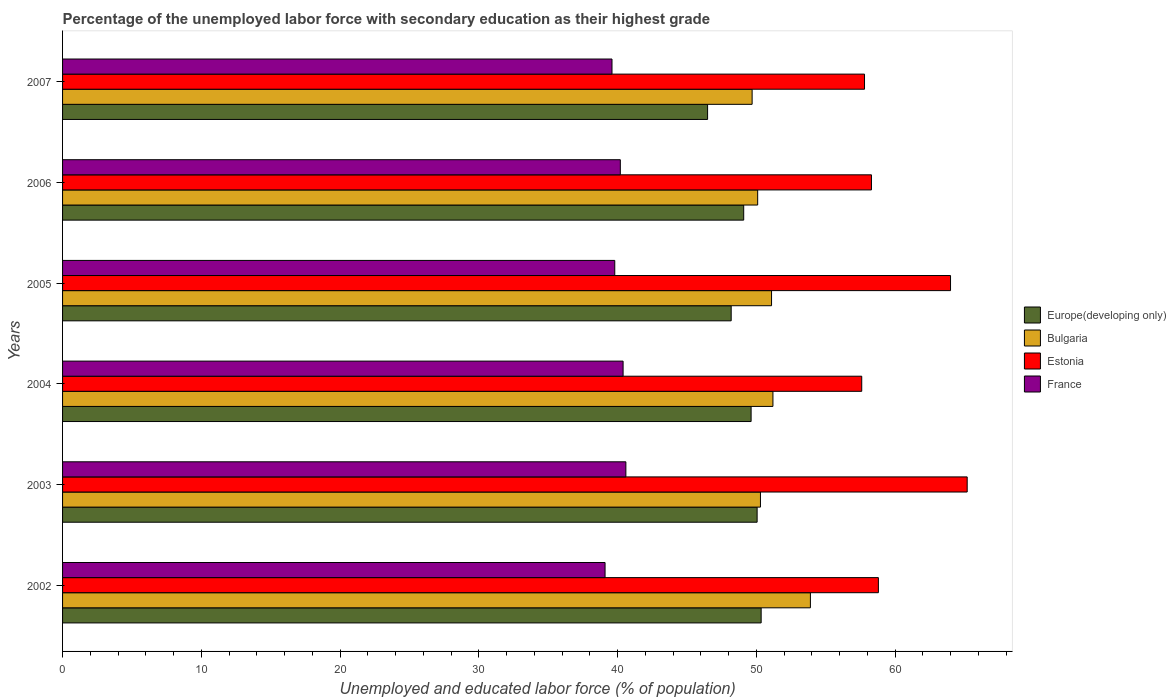How many different coloured bars are there?
Your response must be concise. 4. How many groups of bars are there?
Your response must be concise. 6. Are the number of bars per tick equal to the number of legend labels?
Your response must be concise. Yes. Are the number of bars on each tick of the Y-axis equal?
Keep it short and to the point. Yes. How many bars are there on the 5th tick from the top?
Offer a very short reply. 4. How many bars are there on the 6th tick from the bottom?
Ensure brevity in your answer.  4. What is the label of the 4th group of bars from the top?
Your answer should be very brief. 2004. In how many cases, is the number of bars for a given year not equal to the number of legend labels?
Your answer should be compact. 0. What is the percentage of the unemployed labor force with secondary education in Europe(developing only) in 2003?
Give a very brief answer. 50.06. Across all years, what is the maximum percentage of the unemployed labor force with secondary education in France?
Your response must be concise. 40.6. Across all years, what is the minimum percentage of the unemployed labor force with secondary education in Europe(developing only)?
Provide a succinct answer. 46.49. What is the total percentage of the unemployed labor force with secondary education in Europe(developing only) in the graph?
Make the answer very short. 293.81. What is the difference between the percentage of the unemployed labor force with secondary education in Europe(developing only) in 2002 and that in 2006?
Your answer should be very brief. 1.26. What is the difference between the percentage of the unemployed labor force with secondary education in Bulgaria in 2004 and the percentage of the unemployed labor force with secondary education in Europe(developing only) in 2002?
Offer a very short reply. 0.85. What is the average percentage of the unemployed labor force with secondary education in Bulgaria per year?
Provide a short and direct response. 51.05. In the year 2003, what is the difference between the percentage of the unemployed labor force with secondary education in France and percentage of the unemployed labor force with secondary education in Estonia?
Keep it short and to the point. -24.6. What is the ratio of the percentage of the unemployed labor force with secondary education in Bulgaria in 2002 to that in 2004?
Provide a succinct answer. 1.05. What is the difference between the highest and the second highest percentage of the unemployed labor force with secondary education in Estonia?
Make the answer very short. 1.2. Is the sum of the percentage of the unemployed labor force with secondary education in Bulgaria in 2004 and 2005 greater than the maximum percentage of the unemployed labor force with secondary education in Estonia across all years?
Keep it short and to the point. Yes. Is it the case that in every year, the sum of the percentage of the unemployed labor force with secondary education in France and percentage of the unemployed labor force with secondary education in Europe(developing only) is greater than the sum of percentage of the unemployed labor force with secondary education in Bulgaria and percentage of the unemployed labor force with secondary education in Estonia?
Keep it short and to the point. No. What does the 3rd bar from the bottom in 2007 represents?
Keep it short and to the point. Estonia. Is it the case that in every year, the sum of the percentage of the unemployed labor force with secondary education in Europe(developing only) and percentage of the unemployed labor force with secondary education in France is greater than the percentage of the unemployed labor force with secondary education in Estonia?
Give a very brief answer. Yes. Are all the bars in the graph horizontal?
Give a very brief answer. Yes. How many years are there in the graph?
Your answer should be compact. 6. What is the difference between two consecutive major ticks on the X-axis?
Make the answer very short. 10. Are the values on the major ticks of X-axis written in scientific E-notation?
Make the answer very short. No. Does the graph contain grids?
Provide a short and direct response. No. How many legend labels are there?
Give a very brief answer. 4. How are the legend labels stacked?
Ensure brevity in your answer.  Vertical. What is the title of the graph?
Provide a short and direct response. Percentage of the unemployed labor force with secondary education as their highest grade. What is the label or title of the X-axis?
Keep it short and to the point. Unemployed and educated labor force (% of population). What is the label or title of the Y-axis?
Keep it short and to the point. Years. What is the Unemployed and educated labor force (% of population) of Europe(developing only) in 2002?
Make the answer very short. 50.35. What is the Unemployed and educated labor force (% of population) of Bulgaria in 2002?
Make the answer very short. 53.9. What is the Unemployed and educated labor force (% of population) of Estonia in 2002?
Your answer should be compact. 58.8. What is the Unemployed and educated labor force (% of population) in France in 2002?
Provide a short and direct response. 39.1. What is the Unemployed and educated labor force (% of population) in Europe(developing only) in 2003?
Offer a very short reply. 50.06. What is the Unemployed and educated labor force (% of population) of Bulgaria in 2003?
Offer a very short reply. 50.3. What is the Unemployed and educated labor force (% of population) in Estonia in 2003?
Your answer should be compact. 65.2. What is the Unemployed and educated labor force (% of population) of France in 2003?
Your answer should be compact. 40.6. What is the Unemployed and educated labor force (% of population) in Europe(developing only) in 2004?
Make the answer very short. 49.63. What is the Unemployed and educated labor force (% of population) of Bulgaria in 2004?
Your response must be concise. 51.2. What is the Unemployed and educated labor force (% of population) of Estonia in 2004?
Ensure brevity in your answer.  57.6. What is the Unemployed and educated labor force (% of population) of France in 2004?
Provide a short and direct response. 40.4. What is the Unemployed and educated labor force (% of population) of Europe(developing only) in 2005?
Your response must be concise. 48.19. What is the Unemployed and educated labor force (% of population) of Bulgaria in 2005?
Keep it short and to the point. 51.1. What is the Unemployed and educated labor force (% of population) in Estonia in 2005?
Offer a terse response. 64. What is the Unemployed and educated labor force (% of population) in France in 2005?
Your response must be concise. 39.8. What is the Unemployed and educated labor force (% of population) in Europe(developing only) in 2006?
Offer a terse response. 49.09. What is the Unemployed and educated labor force (% of population) of Bulgaria in 2006?
Your response must be concise. 50.1. What is the Unemployed and educated labor force (% of population) of Estonia in 2006?
Offer a terse response. 58.3. What is the Unemployed and educated labor force (% of population) of France in 2006?
Provide a succinct answer. 40.2. What is the Unemployed and educated labor force (% of population) in Europe(developing only) in 2007?
Offer a terse response. 46.49. What is the Unemployed and educated labor force (% of population) of Bulgaria in 2007?
Your response must be concise. 49.7. What is the Unemployed and educated labor force (% of population) of Estonia in 2007?
Your answer should be compact. 57.8. What is the Unemployed and educated labor force (% of population) in France in 2007?
Offer a terse response. 39.6. Across all years, what is the maximum Unemployed and educated labor force (% of population) of Europe(developing only)?
Give a very brief answer. 50.35. Across all years, what is the maximum Unemployed and educated labor force (% of population) in Bulgaria?
Provide a succinct answer. 53.9. Across all years, what is the maximum Unemployed and educated labor force (% of population) in Estonia?
Make the answer very short. 65.2. Across all years, what is the maximum Unemployed and educated labor force (% of population) of France?
Make the answer very short. 40.6. Across all years, what is the minimum Unemployed and educated labor force (% of population) in Europe(developing only)?
Your answer should be compact. 46.49. Across all years, what is the minimum Unemployed and educated labor force (% of population) of Bulgaria?
Offer a terse response. 49.7. Across all years, what is the minimum Unemployed and educated labor force (% of population) in Estonia?
Your answer should be compact. 57.6. Across all years, what is the minimum Unemployed and educated labor force (% of population) of France?
Your answer should be very brief. 39.1. What is the total Unemployed and educated labor force (% of population) of Europe(developing only) in the graph?
Offer a terse response. 293.81. What is the total Unemployed and educated labor force (% of population) in Bulgaria in the graph?
Make the answer very short. 306.3. What is the total Unemployed and educated labor force (% of population) of Estonia in the graph?
Offer a terse response. 361.7. What is the total Unemployed and educated labor force (% of population) of France in the graph?
Your response must be concise. 239.7. What is the difference between the Unemployed and educated labor force (% of population) of Europe(developing only) in 2002 and that in 2003?
Offer a very short reply. 0.29. What is the difference between the Unemployed and educated labor force (% of population) of Bulgaria in 2002 and that in 2003?
Give a very brief answer. 3.6. What is the difference between the Unemployed and educated labor force (% of population) in Estonia in 2002 and that in 2003?
Your answer should be compact. -6.4. What is the difference between the Unemployed and educated labor force (% of population) in Europe(developing only) in 2002 and that in 2004?
Make the answer very short. 0.72. What is the difference between the Unemployed and educated labor force (% of population) of Bulgaria in 2002 and that in 2004?
Your answer should be very brief. 2.7. What is the difference between the Unemployed and educated labor force (% of population) in Estonia in 2002 and that in 2004?
Give a very brief answer. 1.2. What is the difference between the Unemployed and educated labor force (% of population) in France in 2002 and that in 2004?
Give a very brief answer. -1.3. What is the difference between the Unemployed and educated labor force (% of population) in Europe(developing only) in 2002 and that in 2005?
Your answer should be very brief. 2.16. What is the difference between the Unemployed and educated labor force (% of population) of Estonia in 2002 and that in 2005?
Your answer should be compact. -5.2. What is the difference between the Unemployed and educated labor force (% of population) in France in 2002 and that in 2005?
Give a very brief answer. -0.7. What is the difference between the Unemployed and educated labor force (% of population) in Europe(developing only) in 2002 and that in 2006?
Your response must be concise. 1.26. What is the difference between the Unemployed and educated labor force (% of population) in France in 2002 and that in 2006?
Provide a succinct answer. -1.1. What is the difference between the Unemployed and educated labor force (% of population) of Europe(developing only) in 2002 and that in 2007?
Provide a succinct answer. 3.86. What is the difference between the Unemployed and educated labor force (% of population) of Bulgaria in 2002 and that in 2007?
Your answer should be very brief. 4.2. What is the difference between the Unemployed and educated labor force (% of population) of Estonia in 2002 and that in 2007?
Ensure brevity in your answer.  1. What is the difference between the Unemployed and educated labor force (% of population) of Europe(developing only) in 2003 and that in 2004?
Make the answer very short. 0.43. What is the difference between the Unemployed and educated labor force (% of population) in Bulgaria in 2003 and that in 2004?
Offer a terse response. -0.9. What is the difference between the Unemployed and educated labor force (% of population) of Estonia in 2003 and that in 2004?
Offer a very short reply. 7.6. What is the difference between the Unemployed and educated labor force (% of population) in Europe(developing only) in 2003 and that in 2005?
Your response must be concise. 1.87. What is the difference between the Unemployed and educated labor force (% of population) in Estonia in 2003 and that in 2005?
Provide a succinct answer. 1.2. What is the difference between the Unemployed and educated labor force (% of population) in France in 2003 and that in 2005?
Ensure brevity in your answer.  0.8. What is the difference between the Unemployed and educated labor force (% of population) of Europe(developing only) in 2003 and that in 2006?
Give a very brief answer. 0.97. What is the difference between the Unemployed and educated labor force (% of population) in France in 2003 and that in 2006?
Provide a succinct answer. 0.4. What is the difference between the Unemployed and educated labor force (% of population) of Europe(developing only) in 2003 and that in 2007?
Provide a succinct answer. 3.57. What is the difference between the Unemployed and educated labor force (% of population) in Estonia in 2003 and that in 2007?
Give a very brief answer. 7.4. What is the difference between the Unemployed and educated labor force (% of population) in Europe(developing only) in 2004 and that in 2005?
Ensure brevity in your answer.  1.44. What is the difference between the Unemployed and educated labor force (% of population) of Bulgaria in 2004 and that in 2005?
Provide a short and direct response. 0.1. What is the difference between the Unemployed and educated labor force (% of population) of France in 2004 and that in 2005?
Give a very brief answer. 0.6. What is the difference between the Unemployed and educated labor force (% of population) in Europe(developing only) in 2004 and that in 2006?
Your answer should be compact. 0.53. What is the difference between the Unemployed and educated labor force (% of population) of Bulgaria in 2004 and that in 2006?
Your response must be concise. 1.1. What is the difference between the Unemployed and educated labor force (% of population) in Europe(developing only) in 2004 and that in 2007?
Make the answer very short. 3.14. What is the difference between the Unemployed and educated labor force (% of population) in Estonia in 2004 and that in 2007?
Provide a succinct answer. -0.2. What is the difference between the Unemployed and educated labor force (% of population) in France in 2004 and that in 2007?
Your answer should be very brief. 0.8. What is the difference between the Unemployed and educated labor force (% of population) of Europe(developing only) in 2005 and that in 2006?
Make the answer very short. -0.9. What is the difference between the Unemployed and educated labor force (% of population) in Bulgaria in 2005 and that in 2006?
Make the answer very short. 1. What is the difference between the Unemployed and educated labor force (% of population) in Estonia in 2005 and that in 2006?
Offer a terse response. 5.7. What is the difference between the Unemployed and educated labor force (% of population) of Europe(developing only) in 2005 and that in 2007?
Offer a terse response. 1.7. What is the difference between the Unemployed and educated labor force (% of population) in Europe(developing only) in 2006 and that in 2007?
Your answer should be compact. 2.6. What is the difference between the Unemployed and educated labor force (% of population) of Europe(developing only) in 2002 and the Unemployed and educated labor force (% of population) of Bulgaria in 2003?
Keep it short and to the point. 0.05. What is the difference between the Unemployed and educated labor force (% of population) in Europe(developing only) in 2002 and the Unemployed and educated labor force (% of population) in Estonia in 2003?
Ensure brevity in your answer.  -14.85. What is the difference between the Unemployed and educated labor force (% of population) in Europe(developing only) in 2002 and the Unemployed and educated labor force (% of population) in France in 2003?
Offer a very short reply. 9.75. What is the difference between the Unemployed and educated labor force (% of population) in Bulgaria in 2002 and the Unemployed and educated labor force (% of population) in Estonia in 2003?
Keep it short and to the point. -11.3. What is the difference between the Unemployed and educated labor force (% of population) in Bulgaria in 2002 and the Unemployed and educated labor force (% of population) in France in 2003?
Provide a short and direct response. 13.3. What is the difference between the Unemployed and educated labor force (% of population) in Estonia in 2002 and the Unemployed and educated labor force (% of population) in France in 2003?
Provide a short and direct response. 18.2. What is the difference between the Unemployed and educated labor force (% of population) in Europe(developing only) in 2002 and the Unemployed and educated labor force (% of population) in Bulgaria in 2004?
Your response must be concise. -0.85. What is the difference between the Unemployed and educated labor force (% of population) in Europe(developing only) in 2002 and the Unemployed and educated labor force (% of population) in Estonia in 2004?
Make the answer very short. -7.25. What is the difference between the Unemployed and educated labor force (% of population) of Europe(developing only) in 2002 and the Unemployed and educated labor force (% of population) of France in 2004?
Your response must be concise. 9.95. What is the difference between the Unemployed and educated labor force (% of population) of Europe(developing only) in 2002 and the Unemployed and educated labor force (% of population) of Bulgaria in 2005?
Provide a short and direct response. -0.75. What is the difference between the Unemployed and educated labor force (% of population) in Europe(developing only) in 2002 and the Unemployed and educated labor force (% of population) in Estonia in 2005?
Your answer should be compact. -13.65. What is the difference between the Unemployed and educated labor force (% of population) of Europe(developing only) in 2002 and the Unemployed and educated labor force (% of population) of France in 2005?
Keep it short and to the point. 10.55. What is the difference between the Unemployed and educated labor force (% of population) in Europe(developing only) in 2002 and the Unemployed and educated labor force (% of population) in Bulgaria in 2006?
Keep it short and to the point. 0.25. What is the difference between the Unemployed and educated labor force (% of population) in Europe(developing only) in 2002 and the Unemployed and educated labor force (% of population) in Estonia in 2006?
Keep it short and to the point. -7.95. What is the difference between the Unemployed and educated labor force (% of population) of Europe(developing only) in 2002 and the Unemployed and educated labor force (% of population) of France in 2006?
Provide a short and direct response. 10.15. What is the difference between the Unemployed and educated labor force (% of population) in Bulgaria in 2002 and the Unemployed and educated labor force (% of population) in Estonia in 2006?
Ensure brevity in your answer.  -4.4. What is the difference between the Unemployed and educated labor force (% of population) in Bulgaria in 2002 and the Unemployed and educated labor force (% of population) in France in 2006?
Your answer should be compact. 13.7. What is the difference between the Unemployed and educated labor force (% of population) of Estonia in 2002 and the Unemployed and educated labor force (% of population) of France in 2006?
Your response must be concise. 18.6. What is the difference between the Unemployed and educated labor force (% of population) of Europe(developing only) in 2002 and the Unemployed and educated labor force (% of population) of Bulgaria in 2007?
Your answer should be very brief. 0.65. What is the difference between the Unemployed and educated labor force (% of population) of Europe(developing only) in 2002 and the Unemployed and educated labor force (% of population) of Estonia in 2007?
Your answer should be compact. -7.45. What is the difference between the Unemployed and educated labor force (% of population) of Europe(developing only) in 2002 and the Unemployed and educated labor force (% of population) of France in 2007?
Offer a very short reply. 10.75. What is the difference between the Unemployed and educated labor force (% of population) in Bulgaria in 2002 and the Unemployed and educated labor force (% of population) in Estonia in 2007?
Ensure brevity in your answer.  -3.9. What is the difference between the Unemployed and educated labor force (% of population) of Estonia in 2002 and the Unemployed and educated labor force (% of population) of France in 2007?
Keep it short and to the point. 19.2. What is the difference between the Unemployed and educated labor force (% of population) in Europe(developing only) in 2003 and the Unemployed and educated labor force (% of population) in Bulgaria in 2004?
Make the answer very short. -1.14. What is the difference between the Unemployed and educated labor force (% of population) in Europe(developing only) in 2003 and the Unemployed and educated labor force (% of population) in Estonia in 2004?
Make the answer very short. -7.54. What is the difference between the Unemployed and educated labor force (% of population) of Europe(developing only) in 2003 and the Unemployed and educated labor force (% of population) of France in 2004?
Your answer should be very brief. 9.66. What is the difference between the Unemployed and educated labor force (% of population) of Bulgaria in 2003 and the Unemployed and educated labor force (% of population) of Estonia in 2004?
Offer a terse response. -7.3. What is the difference between the Unemployed and educated labor force (% of population) in Estonia in 2003 and the Unemployed and educated labor force (% of population) in France in 2004?
Your response must be concise. 24.8. What is the difference between the Unemployed and educated labor force (% of population) in Europe(developing only) in 2003 and the Unemployed and educated labor force (% of population) in Bulgaria in 2005?
Your answer should be compact. -1.04. What is the difference between the Unemployed and educated labor force (% of population) in Europe(developing only) in 2003 and the Unemployed and educated labor force (% of population) in Estonia in 2005?
Provide a short and direct response. -13.94. What is the difference between the Unemployed and educated labor force (% of population) in Europe(developing only) in 2003 and the Unemployed and educated labor force (% of population) in France in 2005?
Ensure brevity in your answer.  10.26. What is the difference between the Unemployed and educated labor force (% of population) in Bulgaria in 2003 and the Unemployed and educated labor force (% of population) in Estonia in 2005?
Give a very brief answer. -13.7. What is the difference between the Unemployed and educated labor force (% of population) in Bulgaria in 2003 and the Unemployed and educated labor force (% of population) in France in 2005?
Provide a succinct answer. 10.5. What is the difference between the Unemployed and educated labor force (% of population) in Estonia in 2003 and the Unemployed and educated labor force (% of population) in France in 2005?
Your answer should be very brief. 25.4. What is the difference between the Unemployed and educated labor force (% of population) in Europe(developing only) in 2003 and the Unemployed and educated labor force (% of population) in Bulgaria in 2006?
Ensure brevity in your answer.  -0.04. What is the difference between the Unemployed and educated labor force (% of population) of Europe(developing only) in 2003 and the Unemployed and educated labor force (% of population) of Estonia in 2006?
Your answer should be very brief. -8.24. What is the difference between the Unemployed and educated labor force (% of population) of Europe(developing only) in 2003 and the Unemployed and educated labor force (% of population) of France in 2006?
Provide a succinct answer. 9.86. What is the difference between the Unemployed and educated labor force (% of population) of Europe(developing only) in 2003 and the Unemployed and educated labor force (% of population) of Bulgaria in 2007?
Give a very brief answer. 0.36. What is the difference between the Unemployed and educated labor force (% of population) in Europe(developing only) in 2003 and the Unemployed and educated labor force (% of population) in Estonia in 2007?
Your answer should be very brief. -7.74. What is the difference between the Unemployed and educated labor force (% of population) in Europe(developing only) in 2003 and the Unemployed and educated labor force (% of population) in France in 2007?
Give a very brief answer. 10.46. What is the difference between the Unemployed and educated labor force (% of population) in Bulgaria in 2003 and the Unemployed and educated labor force (% of population) in Estonia in 2007?
Your response must be concise. -7.5. What is the difference between the Unemployed and educated labor force (% of population) in Bulgaria in 2003 and the Unemployed and educated labor force (% of population) in France in 2007?
Offer a terse response. 10.7. What is the difference between the Unemployed and educated labor force (% of population) in Estonia in 2003 and the Unemployed and educated labor force (% of population) in France in 2007?
Your answer should be compact. 25.6. What is the difference between the Unemployed and educated labor force (% of population) of Europe(developing only) in 2004 and the Unemployed and educated labor force (% of population) of Bulgaria in 2005?
Your response must be concise. -1.47. What is the difference between the Unemployed and educated labor force (% of population) of Europe(developing only) in 2004 and the Unemployed and educated labor force (% of population) of Estonia in 2005?
Your answer should be compact. -14.37. What is the difference between the Unemployed and educated labor force (% of population) in Europe(developing only) in 2004 and the Unemployed and educated labor force (% of population) in France in 2005?
Provide a succinct answer. 9.83. What is the difference between the Unemployed and educated labor force (% of population) in Europe(developing only) in 2004 and the Unemployed and educated labor force (% of population) in Bulgaria in 2006?
Offer a terse response. -0.47. What is the difference between the Unemployed and educated labor force (% of population) of Europe(developing only) in 2004 and the Unemployed and educated labor force (% of population) of Estonia in 2006?
Your answer should be very brief. -8.67. What is the difference between the Unemployed and educated labor force (% of population) in Europe(developing only) in 2004 and the Unemployed and educated labor force (% of population) in France in 2006?
Offer a terse response. 9.43. What is the difference between the Unemployed and educated labor force (% of population) of Bulgaria in 2004 and the Unemployed and educated labor force (% of population) of Estonia in 2006?
Offer a very short reply. -7.1. What is the difference between the Unemployed and educated labor force (% of population) in Europe(developing only) in 2004 and the Unemployed and educated labor force (% of population) in Bulgaria in 2007?
Give a very brief answer. -0.07. What is the difference between the Unemployed and educated labor force (% of population) in Europe(developing only) in 2004 and the Unemployed and educated labor force (% of population) in Estonia in 2007?
Keep it short and to the point. -8.17. What is the difference between the Unemployed and educated labor force (% of population) in Europe(developing only) in 2004 and the Unemployed and educated labor force (% of population) in France in 2007?
Keep it short and to the point. 10.03. What is the difference between the Unemployed and educated labor force (% of population) in Bulgaria in 2004 and the Unemployed and educated labor force (% of population) in France in 2007?
Offer a terse response. 11.6. What is the difference between the Unemployed and educated labor force (% of population) of Europe(developing only) in 2005 and the Unemployed and educated labor force (% of population) of Bulgaria in 2006?
Provide a succinct answer. -1.91. What is the difference between the Unemployed and educated labor force (% of population) of Europe(developing only) in 2005 and the Unemployed and educated labor force (% of population) of Estonia in 2006?
Offer a very short reply. -10.11. What is the difference between the Unemployed and educated labor force (% of population) in Europe(developing only) in 2005 and the Unemployed and educated labor force (% of population) in France in 2006?
Provide a succinct answer. 7.99. What is the difference between the Unemployed and educated labor force (% of population) of Bulgaria in 2005 and the Unemployed and educated labor force (% of population) of Estonia in 2006?
Make the answer very short. -7.2. What is the difference between the Unemployed and educated labor force (% of population) in Estonia in 2005 and the Unemployed and educated labor force (% of population) in France in 2006?
Your answer should be very brief. 23.8. What is the difference between the Unemployed and educated labor force (% of population) in Europe(developing only) in 2005 and the Unemployed and educated labor force (% of population) in Bulgaria in 2007?
Your response must be concise. -1.51. What is the difference between the Unemployed and educated labor force (% of population) in Europe(developing only) in 2005 and the Unemployed and educated labor force (% of population) in Estonia in 2007?
Ensure brevity in your answer.  -9.61. What is the difference between the Unemployed and educated labor force (% of population) in Europe(developing only) in 2005 and the Unemployed and educated labor force (% of population) in France in 2007?
Offer a very short reply. 8.59. What is the difference between the Unemployed and educated labor force (% of population) in Bulgaria in 2005 and the Unemployed and educated labor force (% of population) in France in 2007?
Your answer should be compact. 11.5. What is the difference between the Unemployed and educated labor force (% of population) in Estonia in 2005 and the Unemployed and educated labor force (% of population) in France in 2007?
Offer a terse response. 24.4. What is the difference between the Unemployed and educated labor force (% of population) of Europe(developing only) in 2006 and the Unemployed and educated labor force (% of population) of Bulgaria in 2007?
Provide a succinct answer. -0.61. What is the difference between the Unemployed and educated labor force (% of population) of Europe(developing only) in 2006 and the Unemployed and educated labor force (% of population) of Estonia in 2007?
Keep it short and to the point. -8.71. What is the difference between the Unemployed and educated labor force (% of population) of Europe(developing only) in 2006 and the Unemployed and educated labor force (% of population) of France in 2007?
Offer a very short reply. 9.49. What is the difference between the Unemployed and educated labor force (% of population) in Bulgaria in 2006 and the Unemployed and educated labor force (% of population) in Estonia in 2007?
Your response must be concise. -7.7. What is the difference between the Unemployed and educated labor force (% of population) of Bulgaria in 2006 and the Unemployed and educated labor force (% of population) of France in 2007?
Give a very brief answer. 10.5. What is the difference between the Unemployed and educated labor force (% of population) of Estonia in 2006 and the Unemployed and educated labor force (% of population) of France in 2007?
Provide a succinct answer. 18.7. What is the average Unemployed and educated labor force (% of population) in Europe(developing only) per year?
Provide a short and direct response. 48.97. What is the average Unemployed and educated labor force (% of population) in Bulgaria per year?
Your answer should be very brief. 51.05. What is the average Unemployed and educated labor force (% of population) of Estonia per year?
Give a very brief answer. 60.28. What is the average Unemployed and educated labor force (% of population) of France per year?
Offer a terse response. 39.95. In the year 2002, what is the difference between the Unemployed and educated labor force (% of population) of Europe(developing only) and Unemployed and educated labor force (% of population) of Bulgaria?
Offer a terse response. -3.55. In the year 2002, what is the difference between the Unemployed and educated labor force (% of population) of Europe(developing only) and Unemployed and educated labor force (% of population) of Estonia?
Keep it short and to the point. -8.45. In the year 2002, what is the difference between the Unemployed and educated labor force (% of population) of Europe(developing only) and Unemployed and educated labor force (% of population) of France?
Give a very brief answer. 11.25. In the year 2002, what is the difference between the Unemployed and educated labor force (% of population) in Bulgaria and Unemployed and educated labor force (% of population) in Estonia?
Offer a very short reply. -4.9. In the year 2003, what is the difference between the Unemployed and educated labor force (% of population) in Europe(developing only) and Unemployed and educated labor force (% of population) in Bulgaria?
Make the answer very short. -0.24. In the year 2003, what is the difference between the Unemployed and educated labor force (% of population) in Europe(developing only) and Unemployed and educated labor force (% of population) in Estonia?
Your answer should be very brief. -15.14. In the year 2003, what is the difference between the Unemployed and educated labor force (% of population) of Europe(developing only) and Unemployed and educated labor force (% of population) of France?
Offer a very short reply. 9.46. In the year 2003, what is the difference between the Unemployed and educated labor force (% of population) of Bulgaria and Unemployed and educated labor force (% of population) of Estonia?
Your response must be concise. -14.9. In the year 2003, what is the difference between the Unemployed and educated labor force (% of population) of Bulgaria and Unemployed and educated labor force (% of population) of France?
Offer a terse response. 9.7. In the year 2003, what is the difference between the Unemployed and educated labor force (% of population) of Estonia and Unemployed and educated labor force (% of population) of France?
Keep it short and to the point. 24.6. In the year 2004, what is the difference between the Unemployed and educated labor force (% of population) in Europe(developing only) and Unemployed and educated labor force (% of population) in Bulgaria?
Ensure brevity in your answer.  -1.57. In the year 2004, what is the difference between the Unemployed and educated labor force (% of population) of Europe(developing only) and Unemployed and educated labor force (% of population) of Estonia?
Your response must be concise. -7.97. In the year 2004, what is the difference between the Unemployed and educated labor force (% of population) of Europe(developing only) and Unemployed and educated labor force (% of population) of France?
Your answer should be compact. 9.23. In the year 2004, what is the difference between the Unemployed and educated labor force (% of population) of Bulgaria and Unemployed and educated labor force (% of population) of Estonia?
Provide a succinct answer. -6.4. In the year 2004, what is the difference between the Unemployed and educated labor force (% of population) of Estonia and Unemployed and educated labor force (% of population) of France?
Your response must be concise. 17.2. In the year 2005, what is the difference between the Unemployed and educated labor force (% of population) of Europe(developing only) and Unemployed and educated labor force (% of population) of Bulgaria?
Your answer should be very brief. -2.91. In the year 2005, what is the difference between the Unemployed and educated labor force (% of population) in Europe(developing only) and Unemployed and educated labor force (% of population) in Estonia?
Your answer should be very brief. -15.81. In the year 2005, what is the difference between the Unemployed and educated labor force (% of population) in Europe(developing only) and Unemployed and educated labor force (% of population) in France?
Your answer should be compact. 8.39. In the year 2005, what is the difference between the Unemployed and educated labor force (% of population) of Bulgaria and Unemployed and educated labor force (% of population) of Estonia?
Your response must be concise. -12.9. In the year 2005, what is the difference between the Unemployed and educated labor force (% of population) in Estonia and Unemployed and educated labor force (% of population) in France?
Make the answer very short. 24.2. In the year 2006, what is the difference between the Unemployed and educated labor force (% of population) of Europe(developing only) and Unemployed and educated labor force (% of population) of Bulgaria?
Provide a short and direct response. -1.01. In the year 2006, what is the difference between the Unemployed and educated labor force (% of population) of Europe(developing only) and Unemployed and educated labor force (% of population) of Estonia?
Offer a terse response. -9.21. In the year 2006, what is the difference between the Unemployed and educated labor force (% of population) in Europe(developing only) and Unemployed and educated labor force (% of population) in France?
Make the answer very short. 8.89. In the year 2006, what is the difference between the Unemployed and educated labor force (% of population) of Bulgaria and Unemployed and educated labor force (% of population) of France?
Offer a very short reply. 9.9. In the year 2007, what is the difference between the Unemployed and educated labor force (% of population) of Europe(developing only) and Unemployed and educated labor force (% of population) of Bulgaria?
Offer a very short reply. -3.21. In the year 2007, what is the difference between the Unemployed and educated labor force (% of population) in Europe(developing only) and Unemployed and educated labor force (% of population) in Estonia?
Offer a very short reply. -11.31. In the year 2007, what is the difference between the Unemployed and educated labor force (% of population) of Europe(developing only) and Unemployed and educated labor force (% of population) of France?
Offer a very short reply. 6.89. In the year 2007, what is the difference between the Unemployed and educated labor force (% of population) of Bulgaria and Unemployed and educated labor force (% of population) of France?
Provide a succinct answer. 10.1. In the year 2007, what is the difference between the Unemployed and educated labor force (% of population) in Estonia and Unemployed and educated labor force (% of population) in France?
Offer a terse response. 18.2. What is the ratio of the Unemployed and educated labor force (% of population) of Bulgaria in 2002 to that in 2003?
Ensure brevity in your answer.  1.07. What is the ratio of the Unemployed and educated labor force (% of population) of Estonia in 2002 to that in 2003?
Your response must be concise. 0.9. What is the ratio of the Unemployed and educated labor force (% of population) of France in 2002 to that in 2003?
Give a very brief answer. 0.96. What is the ratio of the Unemployed and educated labor force (% of population) of Europe(developing only) in 2002 to that in 2004?
Your response must be concise. 1.01. What is the ratio of the Unemployed and educated labor force (% of population) in Bulgaria in 2002 to that in 2004?
Your answer should be very brief. 1.05. What is the ratio of the Unemployed and educated labor force (% of population) of Estonia in 2002 to that in 2004?
Offer a very short reply. 1.02. What is the ratio of the Unemployed and educated labor force (% of population) of France in 2002 to that in 2004?
Give a very brief answer. 0.97. What is the ratio of the Unemployed and educated labor force (% of population) of Europe(developing only) in 2002 to that in 2005?
Provide a succinct answer. 1.04. What is the ratio of the Unemployed and educated labor force (% of population) in Bulgaria in 2002 to that in 2005?
Your answer should be compact. 1.05. What is the ratio of the Unemployed and educated labor force (% of population) in Estonia in 2002 to that in 2005?
Ensure brevity in your answer.  0.92. What is the ratio of the Unemployed and educated labor force (% of population) in France in 2002 to that in 2005?
Ensure brevity in your answer.  0.98. What is the ratio of the Unemployed and educated labor force (% of population) in Europe(developing only) in 2002 to that in 2006?
Your response must be concise. 1.03. What is the ratio of the Unemployed and educated labor force (% of population) of Bulgaria in 2002 to that in 2006?
Provide a succinct answer. 1.08. What is the ratio of the Unemployed and educated labor force (% of population) of Estonia in 2002 to that in 2006?
Offer a terse response. 1.01. What is the ratio of the Unemployed and educated labor force (% of population) in France in 2002 to that in 2006?
Offer a terse response. 0.97. What is the ratio of the Unemployed and educated labor force (% of population) in Europe(developing only) in 2002 to that in 2007?
Provide a short and direct response. 1.08. What is the ratio of the Unemployed and educated labor force (% of population) of Bulgaria in 2002 to that in 2007?
Ensure brevity in your answer.  1.08. What is the ratio of the Unemployed and educated labor force (% of population) of Estonia in 2002 to that in 2007?
Keep it short and to the point. 1.02. What is the ratio of the Unemployed and educated labor force (% of population) of France in 2002 to that in 2007?
Keep it short and to the point. 0.99. What is the ratio of the Unemployed and educated labor force (% of population) in Europe(developing only) in 2003 to that in 2004?
Your answer should be very brief. 1.01. What is the ratio of the Unemployed and educated labor force (% of population) of Bulgaria in 2003 to that in 2004?
Your answer should be very brief. 0.98. What is the ratio of the Unemployed and educated labor force (% of population) of Estonia in 2003 to that in 2004?
Provide a succinct answer. 1.13. What is the ratio of the Unemployed and educated labor force (% of population) in Europe(developing only) in 2003 to that in 2005?
Your answer should be very brief. 1.04. What is the ratio of the Unemployed and educated labor force (% of population) of Bulgaria in 2003 to that in 2005?
Your answer should be compact. 0.98. What is the ratio of the Unemployed and educated labor force (% of population) of Estonia in 2003 to that in 2005?
Offer a terse response. 1.02. What is the ratio of the Unemployed and educated labor force (% of population) of France in 2003 to that in 2005?
Provide a succinct answer. 1.02. What is the ratio of the Unemployed and educated labor force (% of population) in Europe(developing only) in 2003 to that in 2006?
Your response must be concise. 1.02. What is the ratio of the Unemployed and educated labor force (% of population) in Bulgaria in 2003 to that in 2006?
Provide a short and direct response. 1. What is the ratio of the Unemployed and educated labor force (% of population) in Estonia in 2003 to that in 2006?
Ensure brevity in your answer.  1.12. What is the ratio of the Unemployed and educated labor force (% of population) of France in 2003 to that in 2006?
Make the answer very short. 1.01. What is the ratio of the Unemployed and educated labor force (% of population) in Europe(developing only) in 2003 to that in 2007?
Offer a terse response. 1.08. What is the ratio of the Unemployed and educated labor force (% of population) of Bulgaria in 2003 to that in 2007?
Provide a succinct answer. 1.01. What is the ratio of the Unemployed and educated labor force (% of population) in Estonia in 2003 to that in 2007?
Ensure brevity in your answer.  1.13. What is the ratio of the Unemployed and educated labor force (% of population) of France in 2003 to that in 2007?
Offer a terse response. 1.03. What is the ratio of the Unemployed and educated labor force (% of population) of Europe(developing only) in 2004 to that in 2005?
Offer a very short reply. 1.03. What is the ratio of the Unemployed and educated labor force (% of population) of France in 2004 to that in 2005?
Your answer should be very brief. 1.02. What is the ratio of the Unemployed and educated labor force (% of population) in Europe(developing only) in 2004 to that in 2006?
Your answer should be very brief. 1.01. What is the ratio of the Unemployed and educated labor force (% of population) of Estonia in 2004 to that in 2006?
Ensure brevity in your answer.  0.99. What is the ratio of the Unemployed and educated labor force (% of population) in Europe(developing only) in 2004 to that in 2007?
Provide a succinct answer. 1.07. What is the ratio of the Unemployed and educated labor force (% of population) of Bulgaria in 2004 to that in 2007?
Provide a short and direct response. 1.03. What is the ratio of the Unemployed and educated labor force (% of population) of France in 2004 to that in 2007?
Make the answer very short. 1.02. What is the ratio of the Unemployed and educated labor force (% of population) in Europe(developing only) in 2005 to that in 2006?
Your response must be concise. 0.98. What is the ratio of the Unemployed and educated labor force (% of population) in Estonia in 2005 to that in 2006?
Your answer should be compact. 1.1. What is the ratio of the Unemployed and educated labor force (% of population) of Europe(developing only) in 2005 to that in 2007?
Ensure brevity in your answer.  1.04. What is the ratio of the Unemployed and educated labor force (% of population) of Bulgaria in 2005 to that in 2007?
Your response must be concise. 1.03. What is the ratio of the Unemployed and educated labor force (% of population) of Estonia in 2005 to that in 2007?
Give a very brief answer. 1.11. What is the ratio of the Unemployed and educated labor force (% of population) of Europe(developing only) in 2006 to that in 2007?
Your answer should be compact. 1.06. What is the ratio of the Unemployed and educated labor force (% of population) of Bulgaria in 2006 to that in 2007?
Give a very brief answer. 1.01. What is the ratio of the Unemployed and educated labor force (% of population) in Estonia in 2006 to that in 2007?
Your answer should be very brief. 1.01. What is the ratio of the Unemployed and educated labor force (% of population) of France in 2006 to that in 2007?
Your response must be concise. 1.02. What is the difference between the highest and the second highest Unemployed and educated labor force (% of population) in Europe(developing only)?
Your response must be concise. 0.29. What is the difference between the highest and the second highest Unemployed and educated labor force (% of population) in France?
Your answer should be compact. 0.2. What is the difference between the highest and the lowest Unemployed and educated labor force (% of population) of Europe(developing only)?
Your response must be concise. 3.86. What is the difference between the highest and the lowest Unemployed and educated labor force (% of population) in Bulgaria?
Make the answer very short. 4.2. 